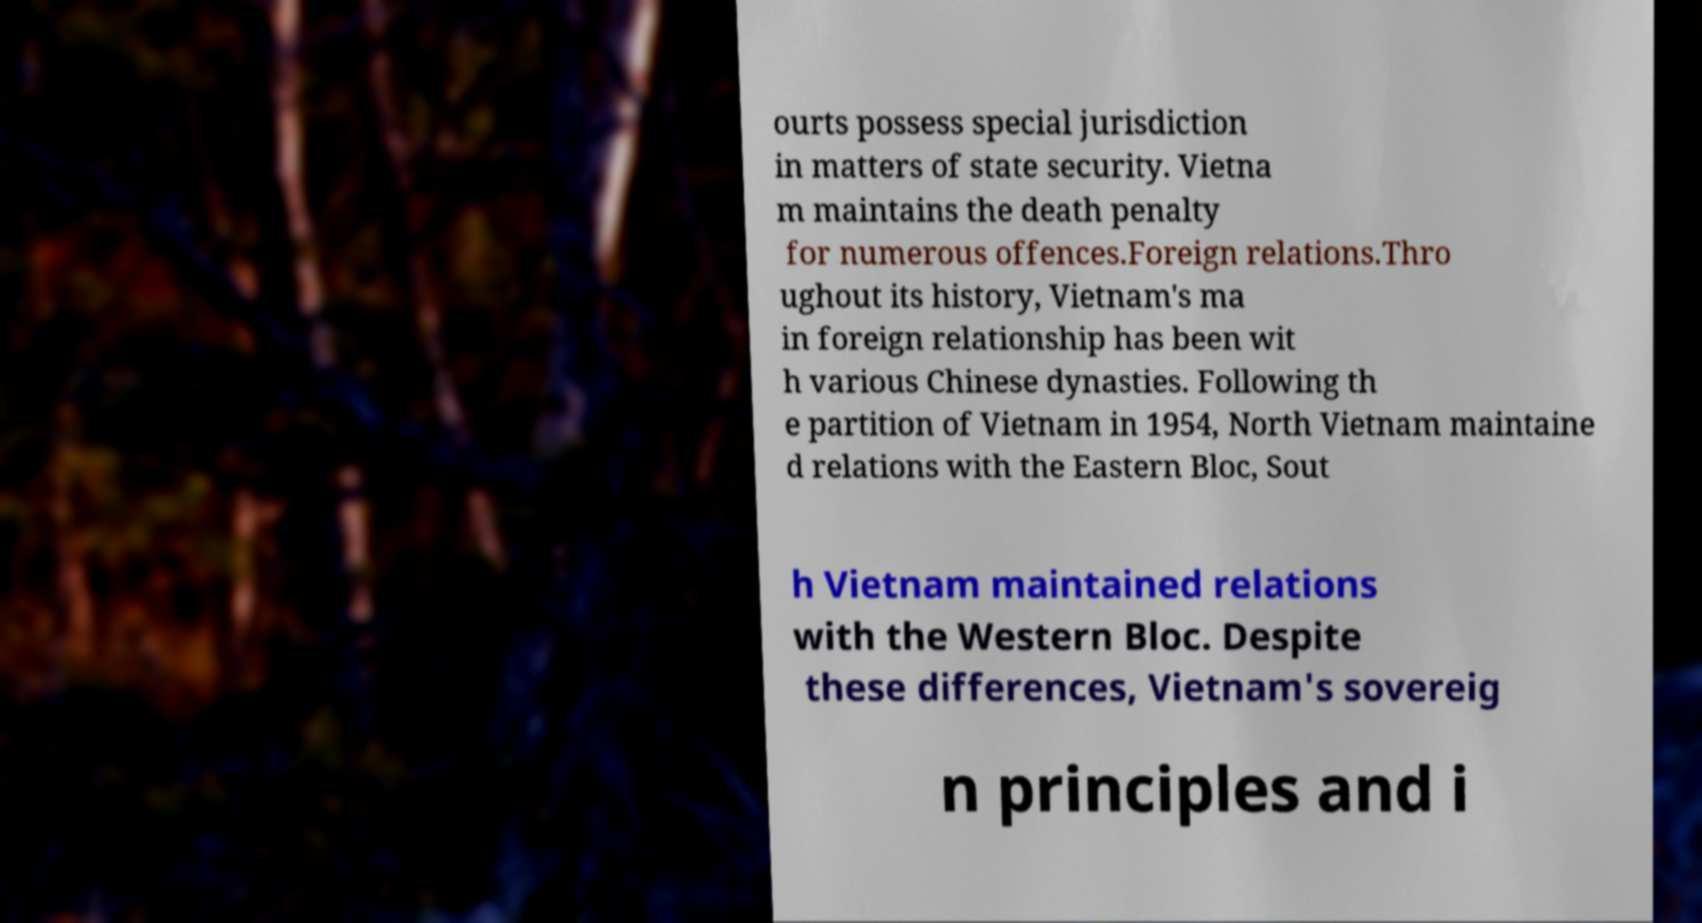Can you accurately transcribe the text from the provided image for me? ourts possess special jurisdiction in matters of state security. Vietna m maintains the death penalty for numerous offences.Foreign relations.Thro ughout its history, Vietnam's ma in foreign relationship has been wit h various Chinese dynasties. Following th e partition of Vietnam in 1954, North Vietnam maintaine d relations with the Eastern Bloc, Sout h Vietnam maintained relations with the Western Bloc. Despite these differences, Vietnam's sovereig n principles and i 